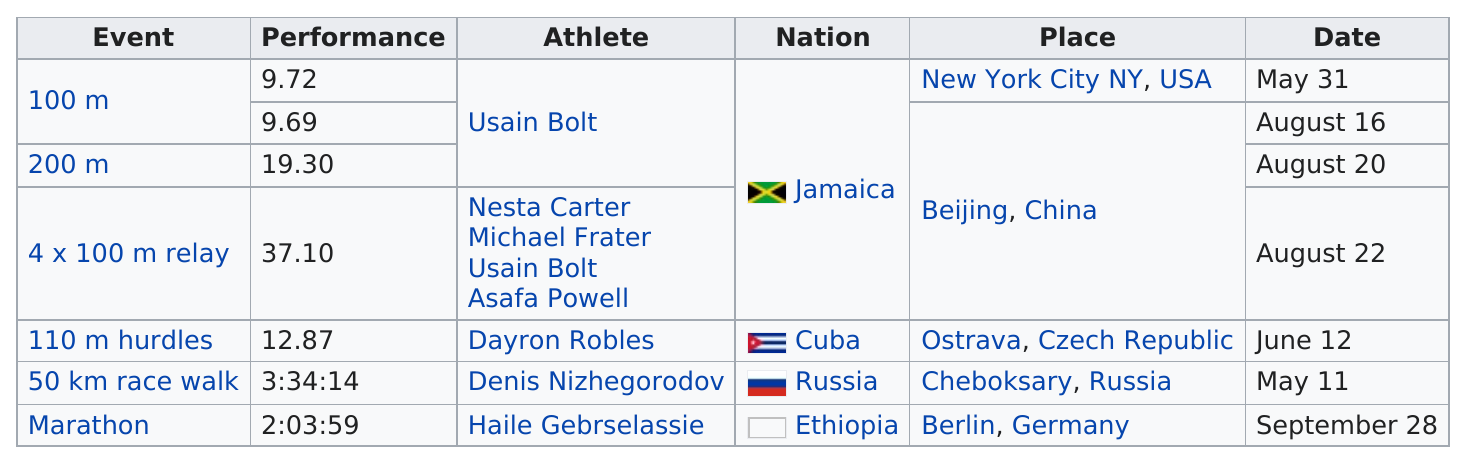Outline some significant characteristics in this image. The person who set at least 2 world records is Usain Bolt. Thirty-three records were set in Beijing. In 2008, Dayron Robles set a new world record in the 110m hurdles with a time of 12.87 seconds during a track and field event. There were a total of three world records that were recorded in August. In 2008, among track and field athletes who set the most world records, Usain Bolt or Haile Gebrselassie? The answer is clear: Usain Bolt broke more world records that year. 